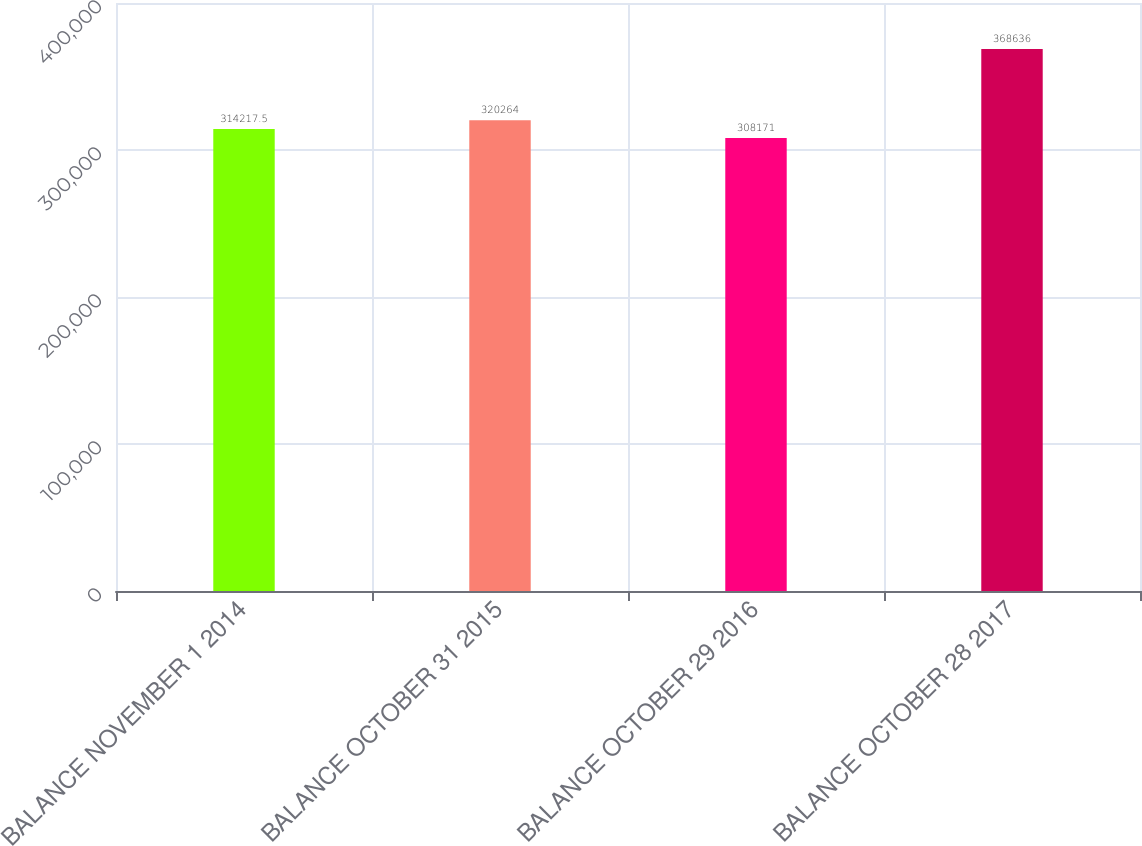Convert chart. <chart><loc_0><loc_0><loc_500><loc_500><bar_chart><fcel>BALANCE NOVEMBER 1 2014<fcel>BALANCE OCTOBER 31 2015<fcel>BALANCE OCTOBER 29 2016<fcel>BALANCE OCTOBER 28 2017<nl><fcel>314218<fcel>320264<fcel>308171<fcel>368636<nl></chart> 